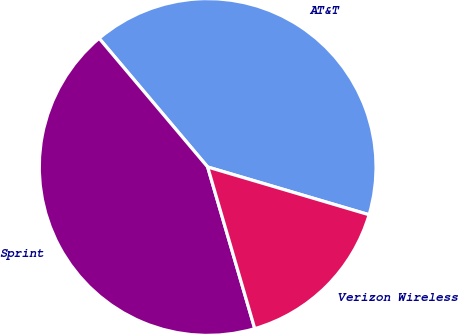Convert chart to OTSL. <chart><loc_0><loc_0><loc_500><loc_500><pie_chart><fcel>AT&T<fcel>Sprint<fcel>Verizon Wireless<nl><fcel>40.73%<fcel>43.36%<fcel>15.91%<nl></chart> 